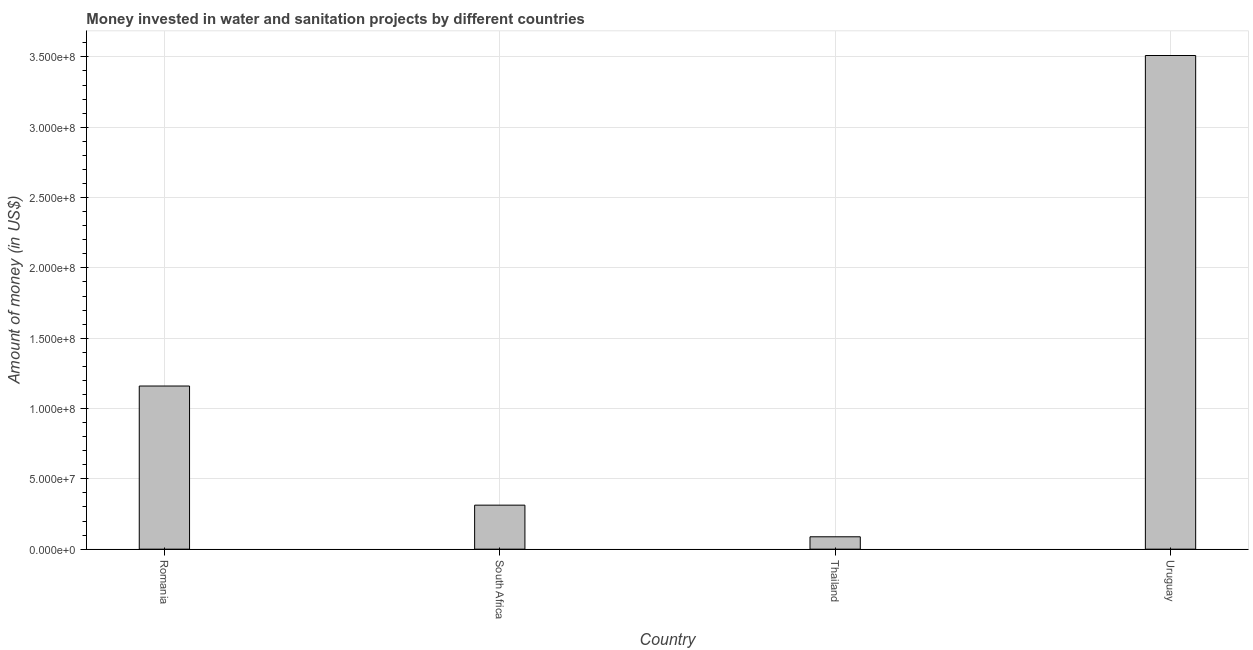Does the graph contain any zero values?
Keep it short and to the point. No. What is the title of the graph?
Offer a terse response. Money invested in water and sanitation projects by different countries. What is the label or title of the Y-axis?
Give a very brief answer. Amount of money (in US$). What is the investment in South Africa?
Ensure brevity in your answer.  3.13e+07. Across all countries, what is the maximum investment?
Provide a short and direct response. 3.51e+08. Across all countries, what is the minimum investment?
Your answer should be very brief. 8.80e+06. In which country was the investment maximum?
Offer a terse response. Uruguay. In which country was the investment minimum?
Offer a very short reply. Thailand. What is the sum of the investment?
Provide a succinct answer. 5.07e+08. What is the difference between the investment in South Africa and Uruguay?
Give a very brief answer. -3.20e+08. What is the average investment per country?
Make the answer very short. 1.27e+08. What is the median investment?
Your answer should be compact. 7.36e+07. What is the ratio of the investment in South Africa to that in Uruguay?
Offer a very short reply. 0.09. Is the investment in Romania less than that in South Africa?
Your answer should be compact. No. What is the difference between the highest and the second highest investment?
Provide a short and direct response. 2.35e+08. Is the sum of the investment in Romania and Uruguay greater than the maximum investment across all countries?
Ensure brevity in your answer.  Yes. What is the difference between the highest and the lowest investment?
Give a very brief answer. 3.42e+08. What is the difference between two consecutive major ticks on the Y-axis?
Your answer should be very brief. 5.00e+07. Are the values on the major ticks of Y-axis written in scientific E-notation?
Offer a terse response. Yes. What is the Amount of money (in US$) in Romania?
Your answer should be compact. 1.16e+08. What is the Amount of money (in US$) in South Africa?
Your answer should be very brief. 3.13e+07. What is the Amount of money (in US$) of Thailand?
Offer a very short reply. 8.80e+06. What is the Amount of money (in US$) in Uruguay?
Offer a very short reply. 3.51e+08. What is the difference between the Amount of money (in US$) in Romania and South Africa?
Make the answer very short. 8.47e+07. What is the difference between the Amount of money (in US$) in Romania and Thailand?
Give a very brief answer. 1.07e+08. What is the difference between the Amount of money (in US$) in Romania and Uruguay?
Give a very brief answer. -2.35e+08. What is the difference between the Amount of money (in US$) in South Africa and Thailand?
Your answer should be very brief. 2.25e+07. What is the difference between the Amount of money (in US$) in South Africa and Uruguay?
Give a very brief answer. -3.20e+08. What is the difference between the Amount of money (in US$) in Thailand and Uruguay?
Make the answer very short. -3.42e+08. What is the ratio of the Amount of money (in US$) in Romania to that in South Africa?
Ensure brevity in your answer.  3.71. What is the ratio of the Amount of money (in US$) in Romania to that in Thailand?
Your answer should be very brief. 13.18. What is the ratio of the Amount of money (in US$) in Romania to that in Uruguay?
Provide a short and direct response. 0.33. What is the ratio of the Amount of money (in US$) in South Africa to that in Thailand?
Give a very brief answer. 3.56. What is the ratio of the Amount of money (in US$) in South Africa to that in Uruguay?
Give a very brief answer. 0.09. What is the ratio of the Amount of money (in US$) in Thailand to that in Uruguay?
Offer a terse response. 0.03. 